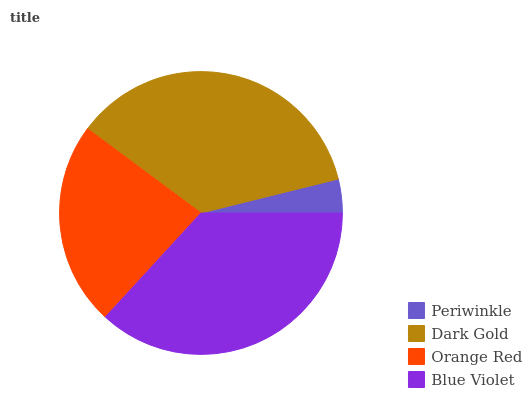Is Periwinkle the minimum?
Answer yes or no. Yes. Is Blue Violet the maximum?
Answer yes or no. Yes. Is Dark Gold the minimum?
Answer yes or no. No. Is Dark Gold the maximum?
Answer yes or no. No. Is Dark Gold greater than Periwinkle?
Answer yes or no. Yes. Is Periwinkle less than Dark Gold?
Answer yes or no. Yes. Is Periwinkle greater than Dark Gold?
Answer yes or no. No. Is Dark Gold less than Periwinkle?
Answer yes or no. No. Is Dark Gold the high median?
Answer yes or no. Yes. Is Orange Red the low median?
Answer yes or no. Yes. Is Blue Violet the high median?
Answer yes or no. No. Is Periwinkle the low median?
Answer yes or no. No. 